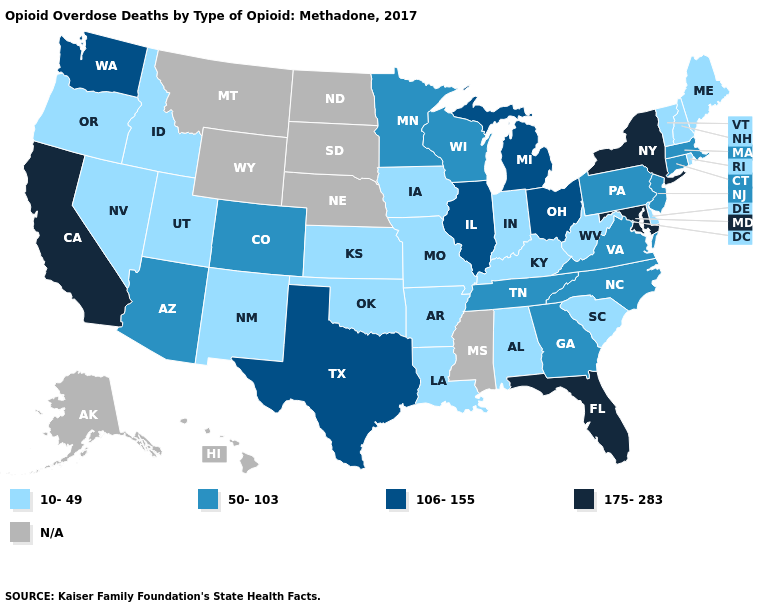Name the states that have a value in the range 50-103?
Short answer required. Arizona, Colorado, Connecticut, Georgia, Massachusetts, Minnesota, New Jersey, North Carolina, Pennsylvania, Tennessee, Virginia, Wisconsin. Does the map have missing data?
Concise answer only. Yes. Name the states that have a value in the range 10-49?
Quick response, please. Alabama, Arkansas, Delaware, Idaho, Indiana, Iowa, Kansas, Kentucky, Louisiana, Maine, Missouri, Nevada, New Hampshire, New Mexico, Oklahoma, Oregon, Rhode Island, South Carolina, Utah, Vermont, West Virginia. Which states hav the highest value in the Northeast?
Be succinct. New York. Is the legend a continuous bar?
Answer briefly. No. How many symbols are there in the legend?
Answer briefly. 5. Which states have the lowest value in the MidWest?
Concise answer only. Indiana, Iowa, Kansas, Missouri. What is the highest value in the USA?
Quick response, please. 175-283. How many symbols are there in the legend?
Write a very short answer. 5. Which states have the lowest value in the West?
Keep it brief. Idaho, Nevada, New Mexico, Oregon, Utah. What is the value of Illinois?
Short answer required. 106-155. What is the highest value in the West ?
Concise answer only. 175-283. Among the states that border Idaho , does Utah have the highest value?
Quick response, please. No. How many symbols are there in the legend?
Write a very short answer. 5. 